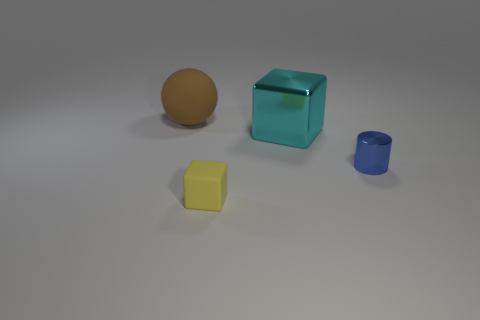Add 3 blue metallic balls. How many objects exist? 7 Subtract all cylinders. How many objects are left? 3 Add 3 balls. How many balls exist? 4 Subtract 0 purple cubes. How many objects are left? 4 Subtract all purple metallic cylinders. Subtract all big cyan blocks. How many objects are left? 3 Add 2 large cyan objects. How many large cyan objects are left? 3 